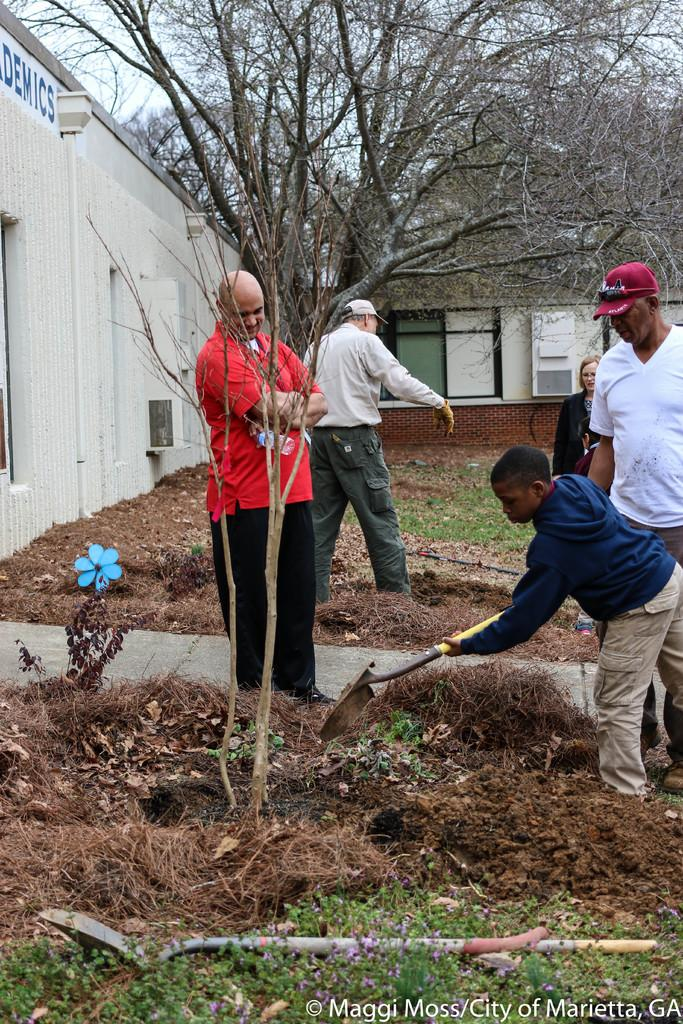What is the kid in the image doing? The kid is digging the soil in the image. How many people are present in the image? There are four people in the image: one kid and three men. What is the woman in the image doing? The provided facts do not specify what the woman is doing. What type of plant can be seen in the image? There is a plant in the image. What is the background of the image? There is a wall and a tree in the background of the image. What type of celery is being washed in the image? There is no celery or washing activity present in the image. 